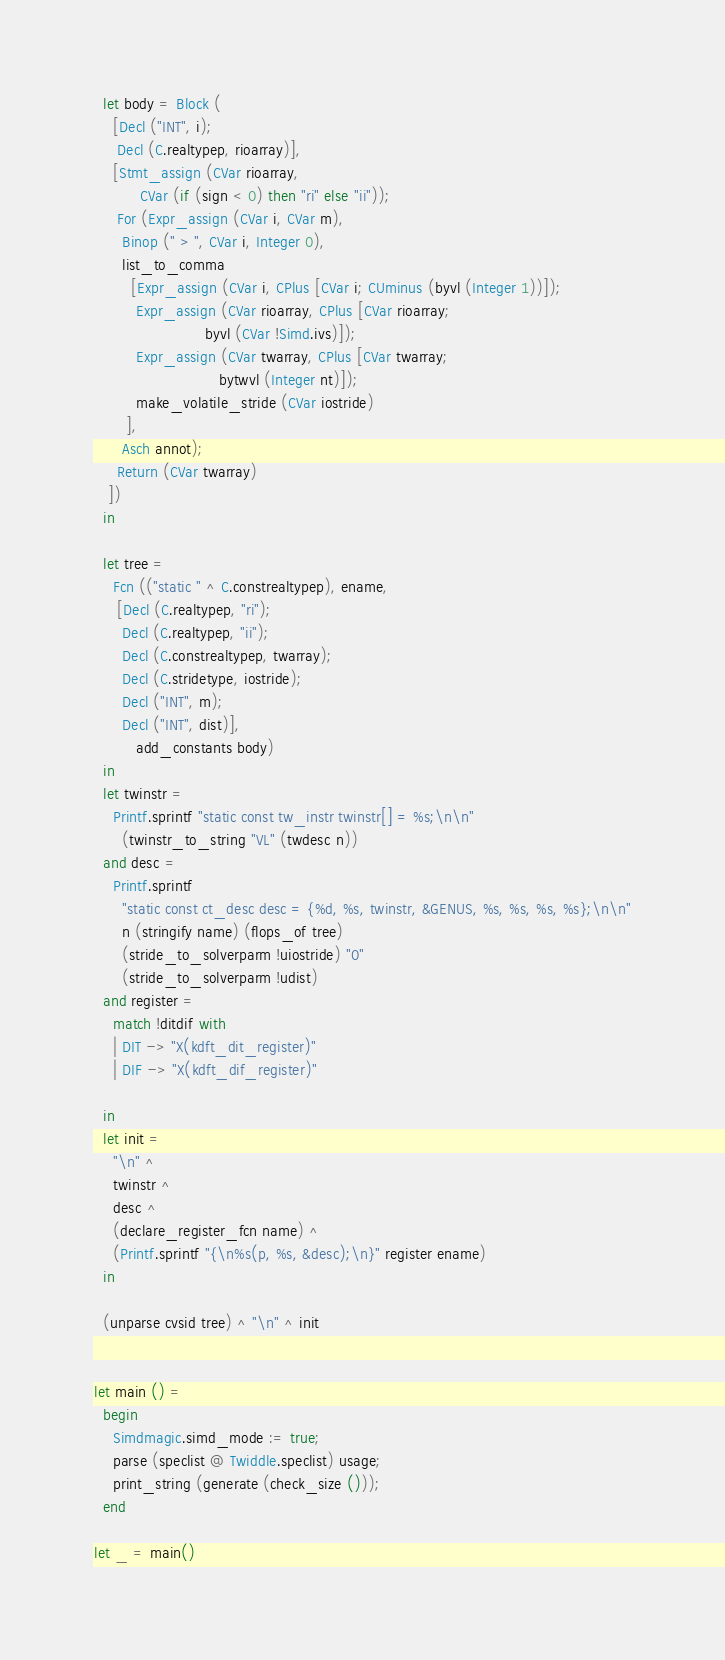Convert code to text. <code><loc_0><loc_0><loc_500><loc_500><_OCaml_>
  let body = Block (
    [Decl ("INT", i);
     Decl (C.realtypep, rioarray)],
    [Stmt_assign (CVar rioarray,
		  CVar (if (sign < 0) then "ri" else "ii"));
     For (Expr_assign (CVar i, CVar m),
	  Binop (" > ", CVar i, Integer 0),
	  list_to_comma 
	    [Expr_assign (CVar i, CPlus [CVar i; CUminus (byvl (Integer 1))]);
	     Expr_assign (CVar rioarray, CPlus [CVar rioarray; 
						byvl (CVar !Simd.ivs)]);
	     Expr_assign (CVar twarray, CPlus [CVar twarray; 
					       bytwvl (Integer nt)]);
	     make_volatile_stride (CVar iostride)
	   ],
	  Asch annot);
     Return (CVar twarray)
   ])
  in

  let tree = 
    Fcn (("static " ^ C.constrealtypep), ename,
	 [Decl (C.realtypep, "ri");
	  Decl (C.realtypep, "ii");
	  Decl (C.constrealtypep, twarray);
	  Decl (C.stridetype, iostride);
	  Decl ("INT", m);
	  Decl ("INT", dist)],
         add_constants body)
  in
  let twinstr = 
    Printf.sprintf "static const tw_instr twinstr[] = %s;\n\n" 
      (twinstr_to_string "VL" (twdesc n))
  and desc = 
    Printf.sprintf
      "static const ct_desc desc = {%d, %s, twinstr, &GENUS, %s, %s, %s, %s};\n\n"
      n (stringify name) (flops_of tree) 
      (stride_to_solverparm !uiostride) "0"
      (stride_to_solverparm !udist) 
  and register = 
    match !ditdif with
    | DIT -> "X(kdft_dit_register)"
    | DIF -> "X(kdft_dif_register)"

  in
  let init =
    "\n" ^
    twinstr ^ 
    desc ^
    (declare_register_fcn name) ^
    (Printf.sprintf "{\n%s(p, %s, &desc);\n}" register ename)
  in

  (unparse cvsid tree) ^ "\n" ^ init


let main () =
  begin 
    Simdmagic.simd_mode := true;
    parse (speclist @ Twiddle.speclist) usage;
    print_string (generate (check_size ()));
  end

let _ = main()
</code> 